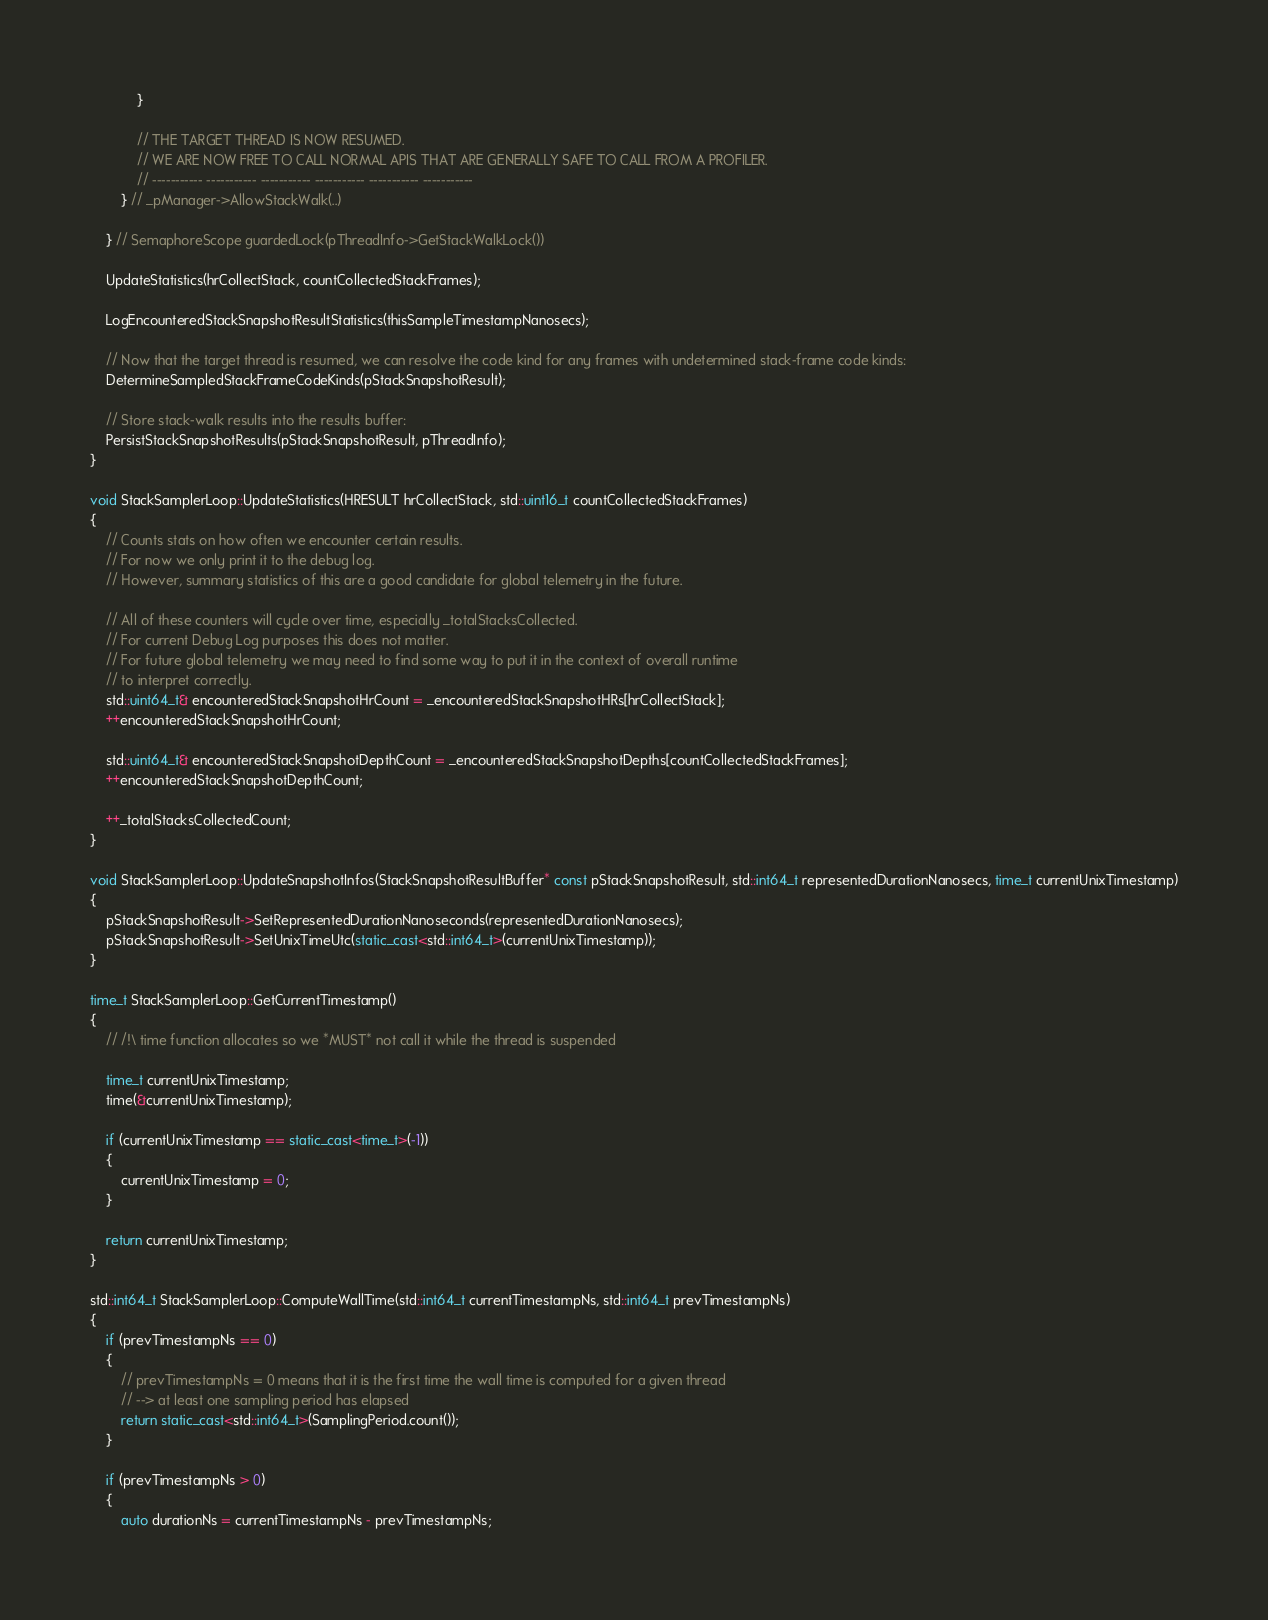<code> <loc_0><loc_0><loc_500><loc_500><_C++_>            }

            // THE TARGET THREAD IS NOW RESUMED.
            // WE ARE NOW FREE TO CALL NORMAL APIS THAT ARE GENERALLY SAFE TO CALL FROM A PROFILER.
            // ----------- ----------- ----------- ----------- ----------- -----------
        } // _pManager->AllowStackWalk(..)

    } // SemaphoreScope guardedLock(pThreadInfo->GetStackWalkLock())

    UpdateStatistics(hrCollectStack, countCollectedStackFrames);

    LogEncounteredStackSnapshotResultStatistics(thisSampleTimestampNanosecs);

    // Now that the target thread is resumed, we can resolve the code kind for any frames with undetermined stack-frame code kinds:
    DetermineSampledStackFrameCodeKinds(pStackSnapshotResult);

    // Store stack-walk results into the results buffer:
    PersistStackSnapshotResults(pStackSnapshotResult, pThreadInfo);
}

void StackSamplerLoop::UpdateStatistics(HRESULT hrCollectStack, std::uint16_t countCollectedStackFrames)
{
    // Counts stats on how often we encounter certain results.
    // For now we only print it to the debug log.
    // However, summary statistics of this are a good candidate for global telemetry in the future.

    // All of these counters will cycle over time, especially _totalStacksCollected.
    // For current Debug Log purposes this does not matter.
    // For future global telemetry we may need to find some way to put it in the context of overall runtime
    // to interpret correctly.
    std::uint64_t& encounteredStackSnapshotHrCount = _encounteredStackSnapshotHRs[hrCollectStack];
    ++encounteredStackSnapshotHrCount;

    std::uint64_t& encounteredStackSnapshotDepthCount = _encounteredStackSnapshotDepths[countCollectedStackFrames];
    ++encounteredStackSnapshotDepthCount;

    ++_totalStacksCollectedCount;
}

void StackSamplerLoop::UpdateSnapshotInfos(StackSnapshotResultBuffer* const pStackSnapshotResult, std::int64_t representedDurationNanosecs, time_t currentUnixTimestamp)
{
    pStackSnapshotResult->SetRepresentedDurationNanoseconds(representedDurationNanosecs);
    pStackSnapshotResult->SetUnixTimeUtc(static_cast<std::int64_t>(currentUnixTimestamp));
}

time_t StackSamplerLoop::GetCurrentTimestamp()
{
    // /!\ time function allocates so we *MUST* not call it while the thread is suspended

    time_t currentUnixTimestamp;
    time(&currentUnixTimestamp);

    if (currentUnixTimestamp == static_cast<time_t>(-1))
    {
        currentUnixTimestamp = 0;
    }

    return currentUnixTimestamp;
}

std::int64_t StackSamplerLoop::ComputeWallTime(std::int64_t currentTimestampNs, std::int64_t prevTimestampNs)
{
    if (prevTimestampNs == 0)
    {
        // prevTimestampNs = 0 means that it is the first time the wall time is computed for a given thread
        // --> at least one sampling period has elapsed
        return static_cast<std::int64_t>(SamplingPeriod.count());
    }

    if (prevTimestampNs > 0)
    {
        auto durationNs = currentTimestampNs - prevTimestampNs;</code> 